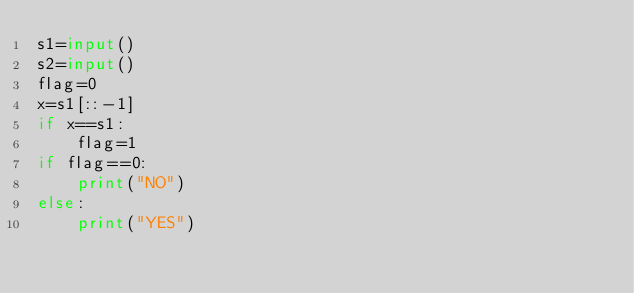Convert code to text. <code><loc_0><loc_0><loc_500><loc_500><_Python_>s1=input()
s2=input()
flag=0
x=s1[::-1]
if x==s1:
    flag=1
if flag==0:
    print("NO")
else:
    print("YES")</code> 